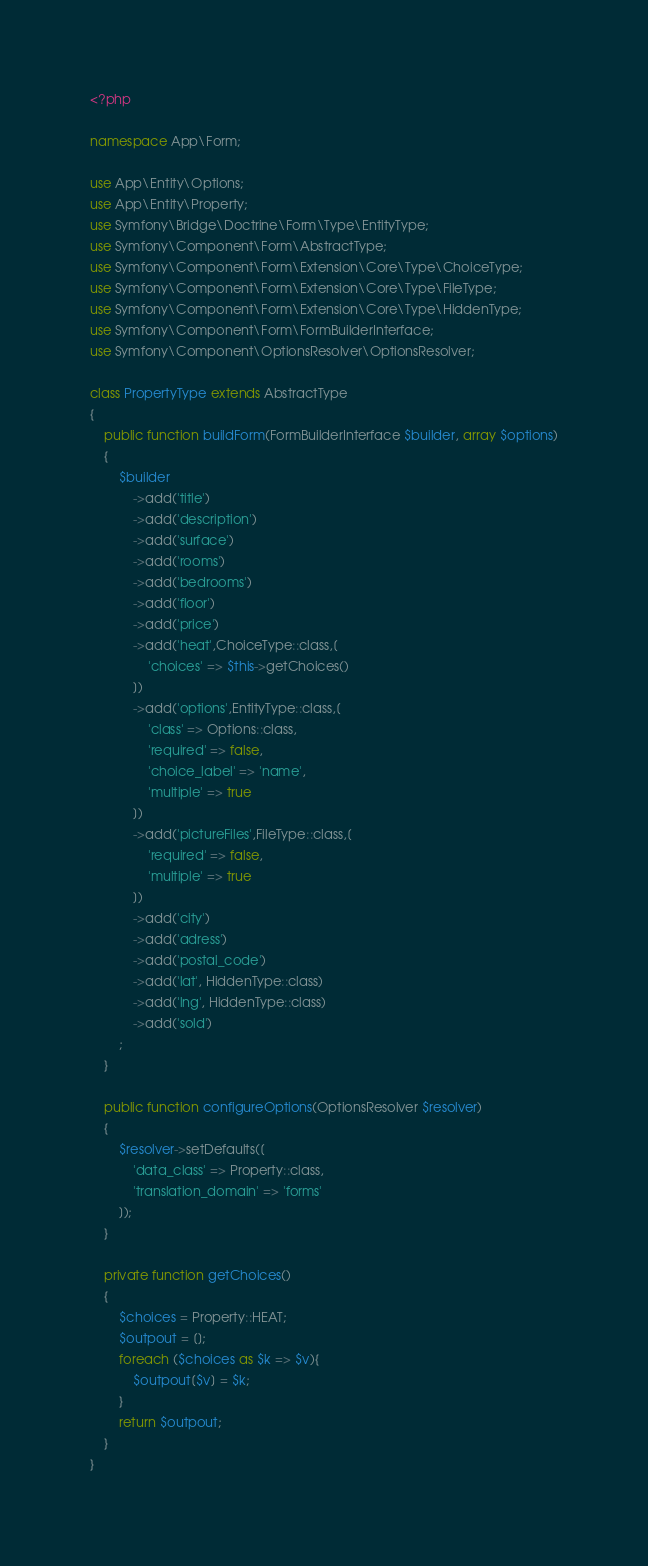<code> <loc_0><loc_0><loc_500><loc_500><_PHP_><?php

namespace App\Form;

use App\Entity\Options;
use App\Entity\Property;
use Symfony\Bridge\Doctrine\Form\Type\EntityType;
use Symfony\Component\Form\AbstractType;
use Symfony\Component\Form\Extension\Core\Type\ChoiceType;
use Symfony\Component\Form\Extension\Core\Type\FileType;
use Symfony\Component\Form\Extension\Core\Type\HiddenType;
use Symfony\Component\Form\FormBuilderInterface;
use Symfony\Component\OptionsResolver\OptionsResolver;

class PropertyType extends AbstractType
{
    public function buildForm(FormBuilderInterface $builder, array $options)
    {
        $builder
            ->add('title')
            ->add('description')
            ->add('surface')
            ->add('rooms')
            ->add('bedrooms')
            ->add('floor')
            ->add('price')
            ->add('heat',ChoiceType::class,[
                'choices' => $this->getChoices()
            ])
            ->add('options',EntityType::class,[
                'class' => Options::class,
                'required' => false,
                'choice_label' => 'name',
                'multiple' => true
            ])
            ->add('pictureFiles',FileType::class,[
                'required' => false,
                'multiple' => true
            ])
            ->add('city')
            ->add('adress')
            ->add('postal_code')
            ->add('lat', HiddenType::class)
            ->add('lng', HiddenType::class)
            ->add('sold')
        ;
    }

    public function configureOptions(OptionsResolver $resolver)
    {
        $resolver->setDefaults([
            'data_class' => Property::class,
            'translation_domain' => 'forms'
        ]);
    }

    private function getChoices()
    {
        $choices = Property::HEAT;
        $outpout = [];
        foreach ($choices as $k => $v){
            $outpout[$v] = $k;
        }
        return $outpout;
    }
}
</code> 